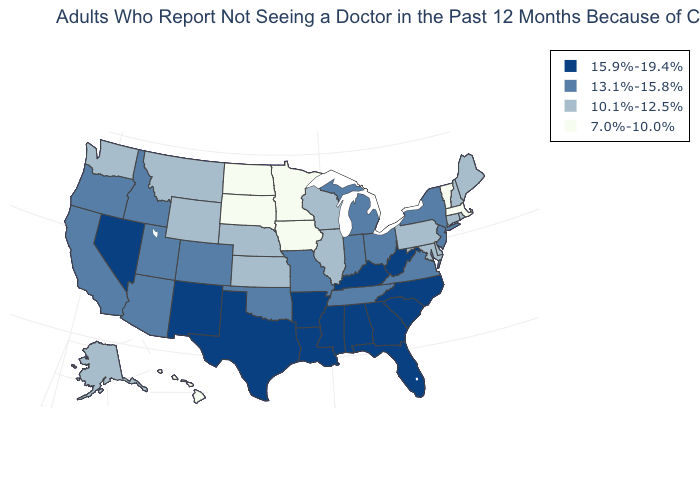What is the lowest value in the MidWest?
Concise answer only. 7.0%-10.0%. Is the legend a continuous bar?
Concise answer only. No. Does North Dakota have the same value as Minnesota?
Answer briefly. Yes. Name the states that have a value in the range 13.1%-15.8%?
Concise answer only. Arizona, California, Colorado, Idaho, Indiana, Michigan, Missouri, New Jersey, New York, Ohio, Oklahoma, Oregon, Tennessee, Utah, Virginia. What is the value of Indiana?
Short answer required. 13.1%-15.8%. Name the states that have a value in the range 15.9%-19.4%?
Write a very short answer. Alabama, Arkansas, Florida, Georgia, Kentucky, Louisiana, Mississippi, Nevada, New Mexico, North Carolina, South Carolina, Texas, West Virginia. What is the value of Wyoming?
Quick response, please. 10.1%-12.5%. Which states have the highest value in the USA?
Write a very short answer. Alabama, Arkansas, Florida, Georgia, Kentucky, Louisiana, Mississippi, Nevada, New Mexico, North Carolina, South Carolina, Texas, West Virginia. What is the highest value in states that border New Mexico?
Answer briefly. 15.9%-19.4%. What is the value of Michigan?
Give a very brief answer. 13.1%-15.8%. What is the value of Maine?
Give a very brief answer. 10.1%-12.5%. What is the value of Arizona?
Short answer required. 13.1%-15.8%. Name the states that have a value in the range 7.0%-10.0%?
Write a very short answer. Hawaii, Iowa, Massachusetts, Minnesota, North Dakota, South Dakota, Vermont. What is the highest value in states that border Nevada?
Write a very short answer. 13.1%-15.8%. Does Wyoming have the highest value in the West?
Quick response, please. No. 